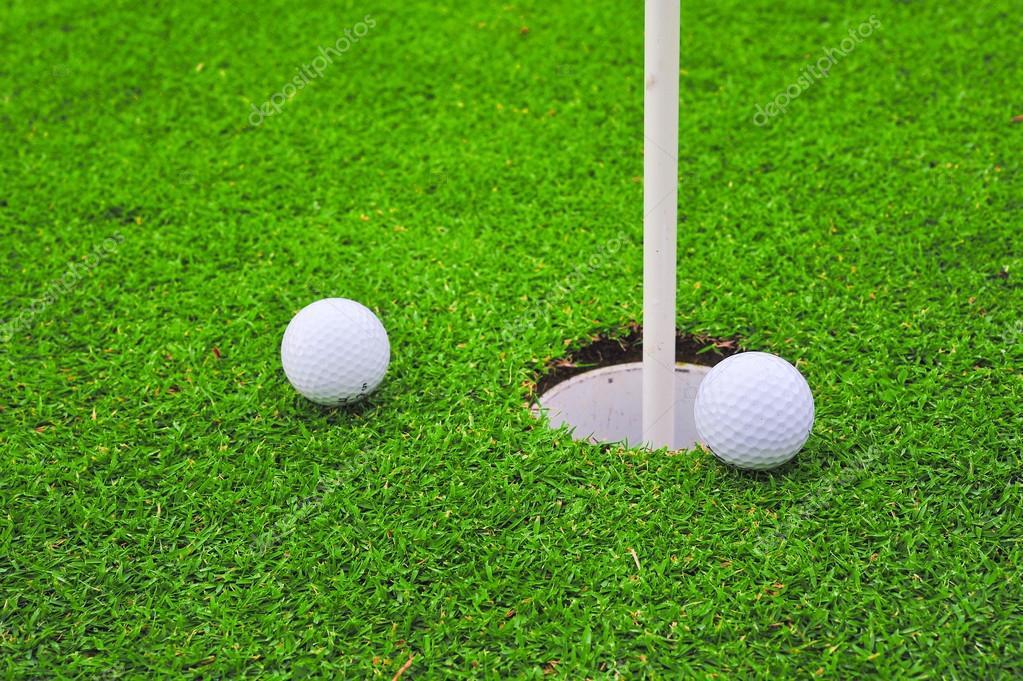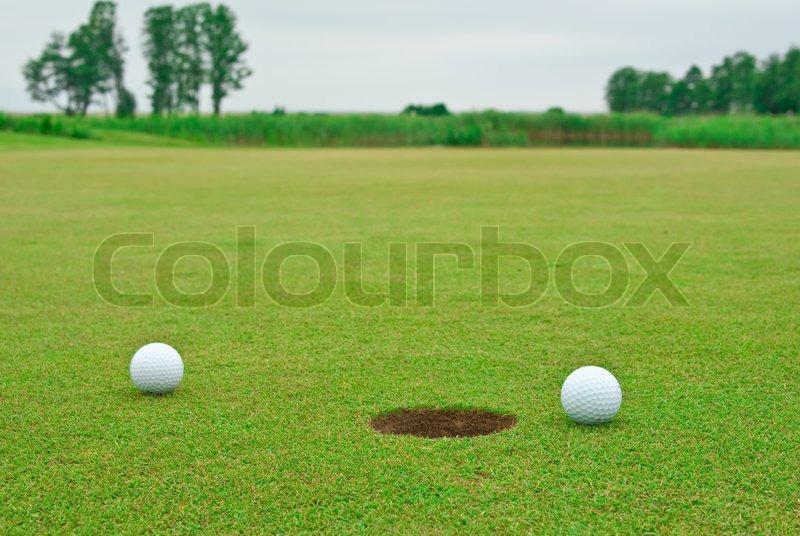The first image is the image on the left, the second image is the image on the right. For the images displayed, is the sentence "An image shows multiple golf balls near a hole with a pole in it." factually correct? Answer yes or no. Yes. The first image is the image on the left, the second image is the image on the right. Given the left and right images, does the statement "In one of the images there are at least two golf balls positioned near a hole with a golf flagpole inserted in it." hold true? Answer yes or no. Yes. 